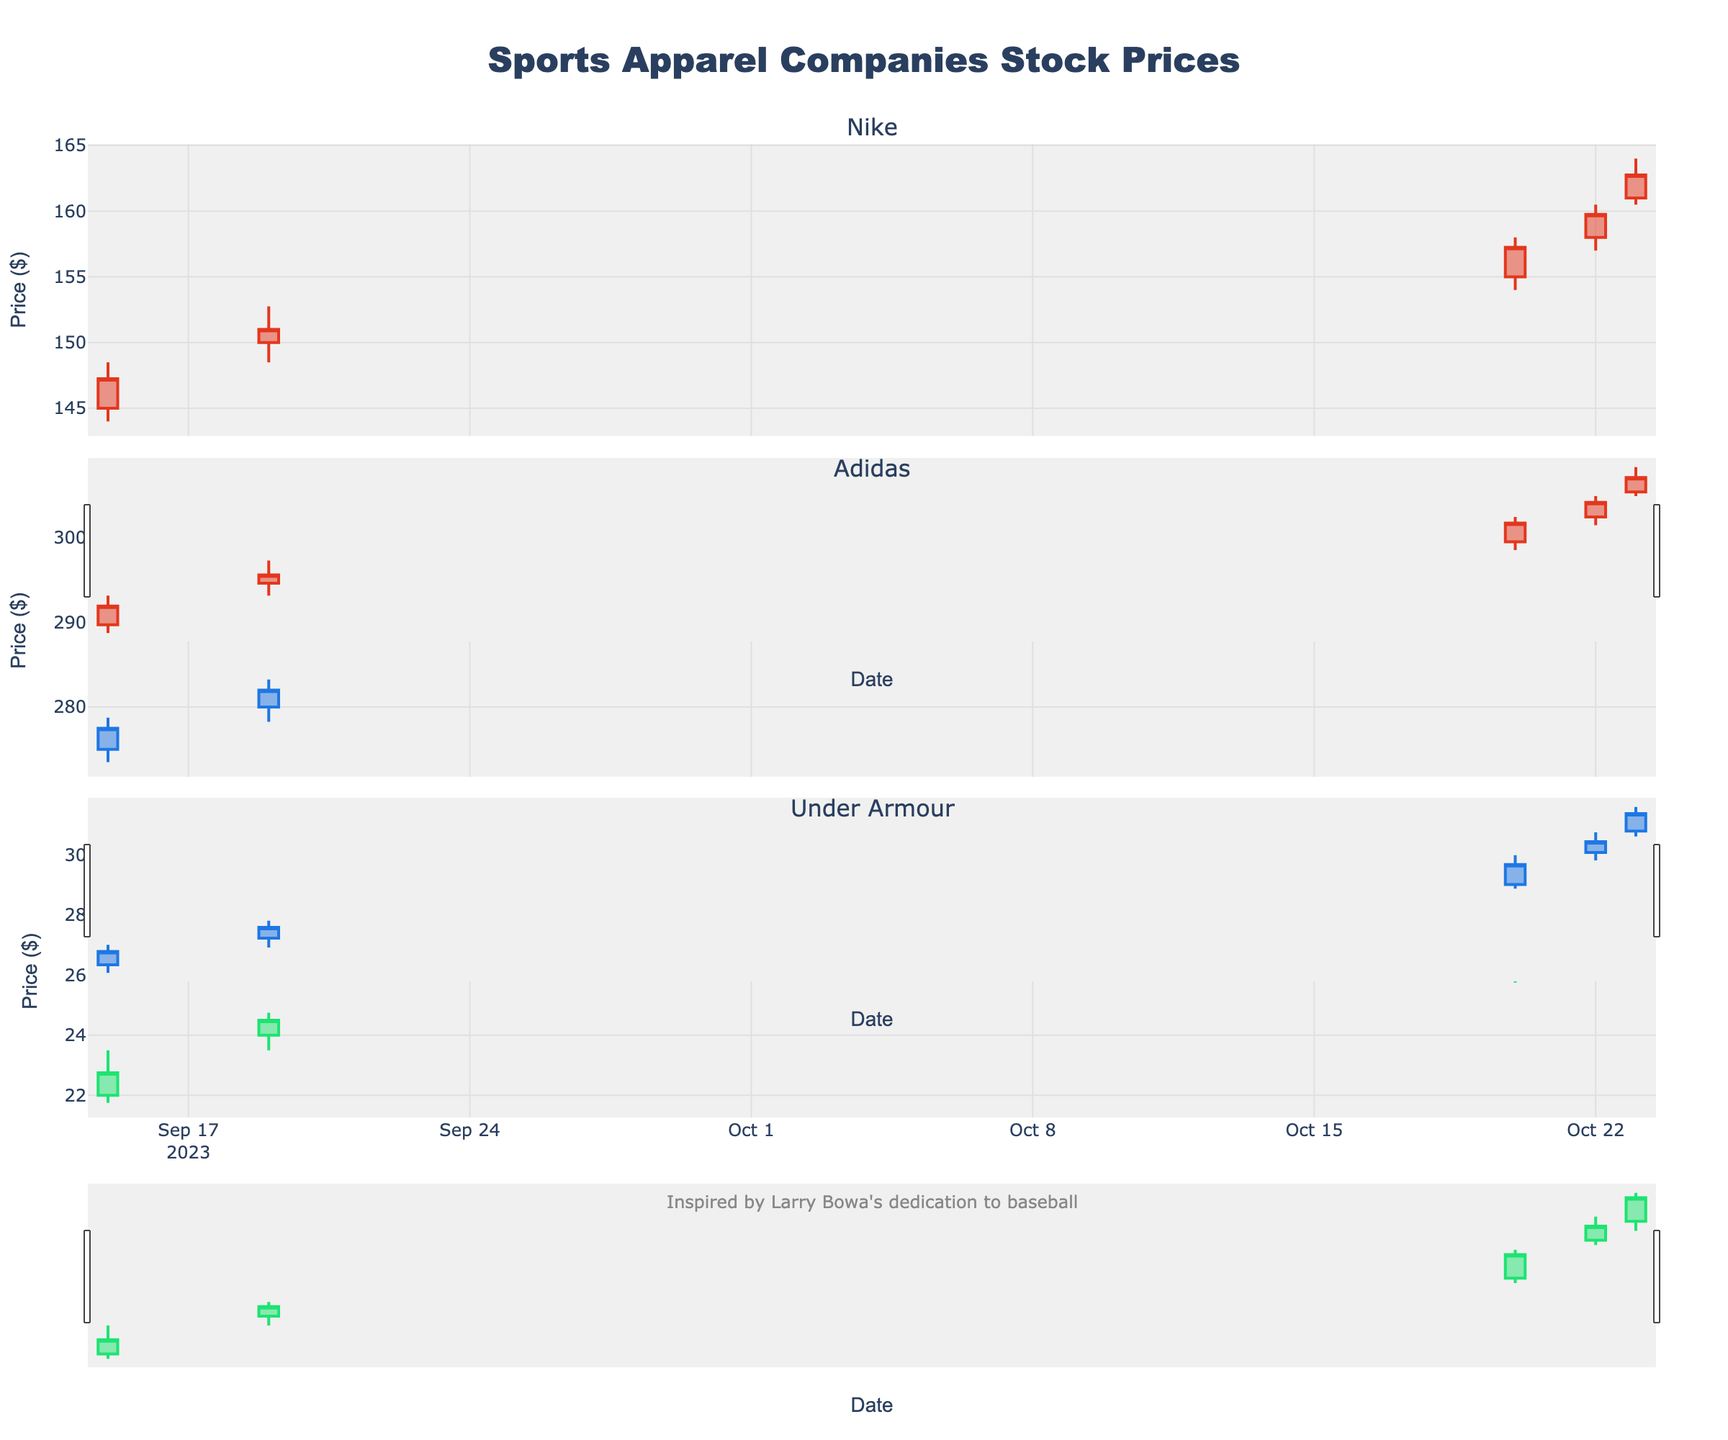What's the overall title of the figure? The figure's overall title is generally displayed at the top center and is clearly readable.
Answer: Sports Apparel Companies Stock Prices Which company's stock price shows the highest closing value on October 23? To find the highest closing value, compare Nike, Adidas, and Under Armour's closing prices on October 23. Nike's closing price is 162.75, Adidas's is 303.25, and Under Armour's is 30.25. Therefore, Adidas has the highest closing value.
Answer: Adidas What was the total volume of Nike stocks traded on October 22 and October 23 combined? Add the volumes from October 22 (4,200,000) and October 23 (4,000,000) to get the total.
Answer: 8,200,000 How did Under Armour’s opening price change from September 15 to October 23? Subtract the opening price on September 15 (22.00) from the opening price on October 23 (29.00).
Answer: It increased by 7.00 Which company had the largest difference between the high and low prices on October 20? Calculate the difference between high and low prices for each company on October 20. Nike's difference is 4.00 (158.00 - 154.00), Adidas's difference is 6.25 (295.50 - 289.25), and Under Armour's difference is 1.75 (27.50 - 25.75). Adidas had the largest difference.
Answer: Adidas What is the color of the increasing lines for Adidas on the plot? The plot uses specific colors for increasing lines. Adidas's increasing lines are colored in '#1E77E3' which translates to a blue shade.
Answer: Blue On which date did Nike's closing price surpass 150 for the first time? Look at the closing prices for Nike. On September 19, the closing price moved past 150 for the first time, closing at 151.00.
Answer: September 19 Which company experienced the highest volume of stocks traded and on what date? Compare the volumes traded across all companies and dates. Under Armour experienced the highest volume traded on October 23 with a volume of 3,600,000.
Answer: Under Armour on October 23 